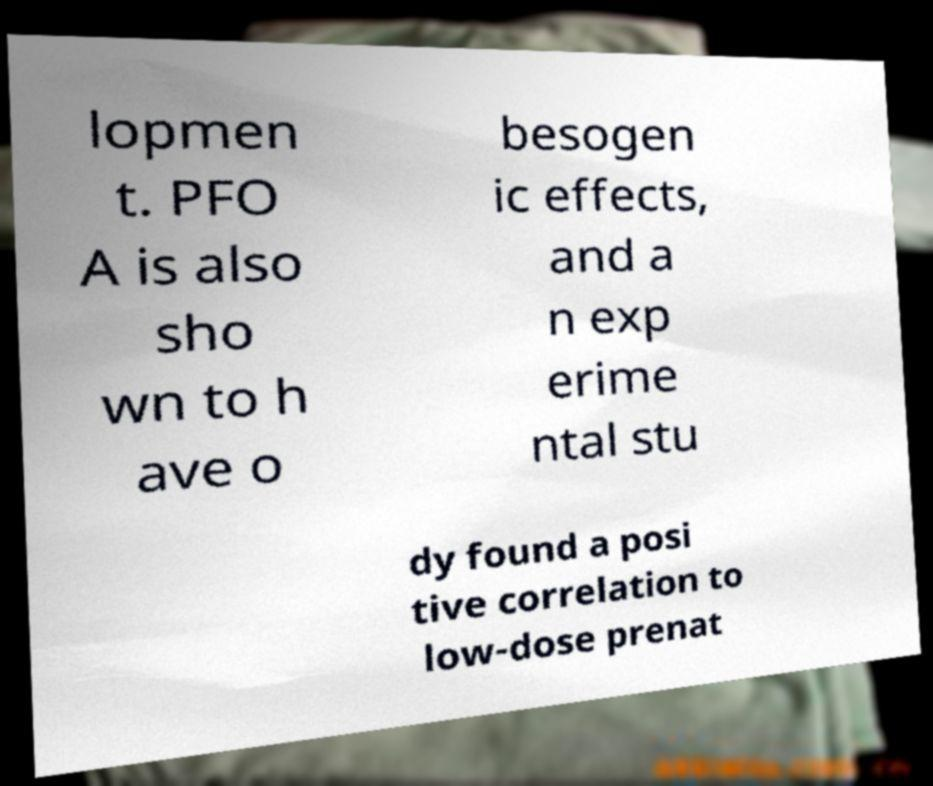For documentation purposes, I need the text within this image transcribed. Could you provide that? lopmen t. PFO A is also sho wn to h ave o besogen ic effects, and a n exp erime ntal stu dy found a posi tive correlation to low-dose prenat 